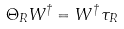<formula> <loc_0><loc_0><loc_500><loc_500>\Theta _ { R } W ^ { \dagger } = W ^ { \dagger } \, \tau _ { R }</formula> 